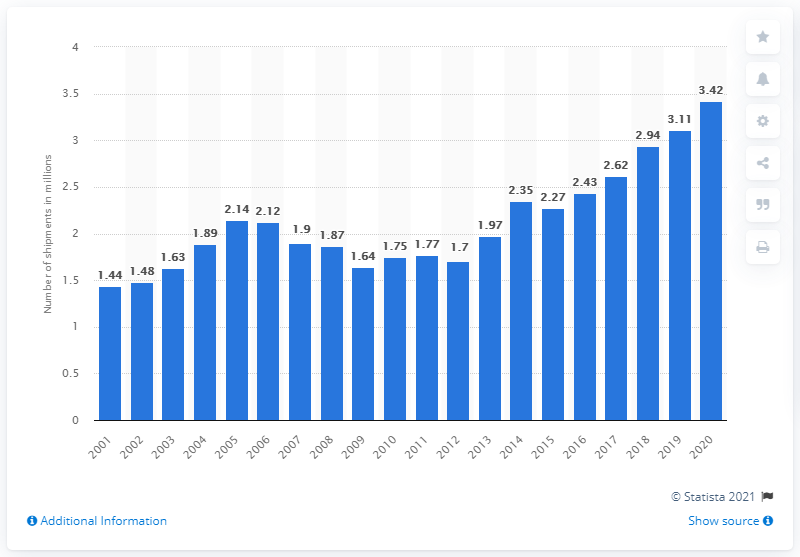List a handful of essential elements in this visual. In 2020, a total of 3,420 air-source heat pumps were shipped in the United States. 